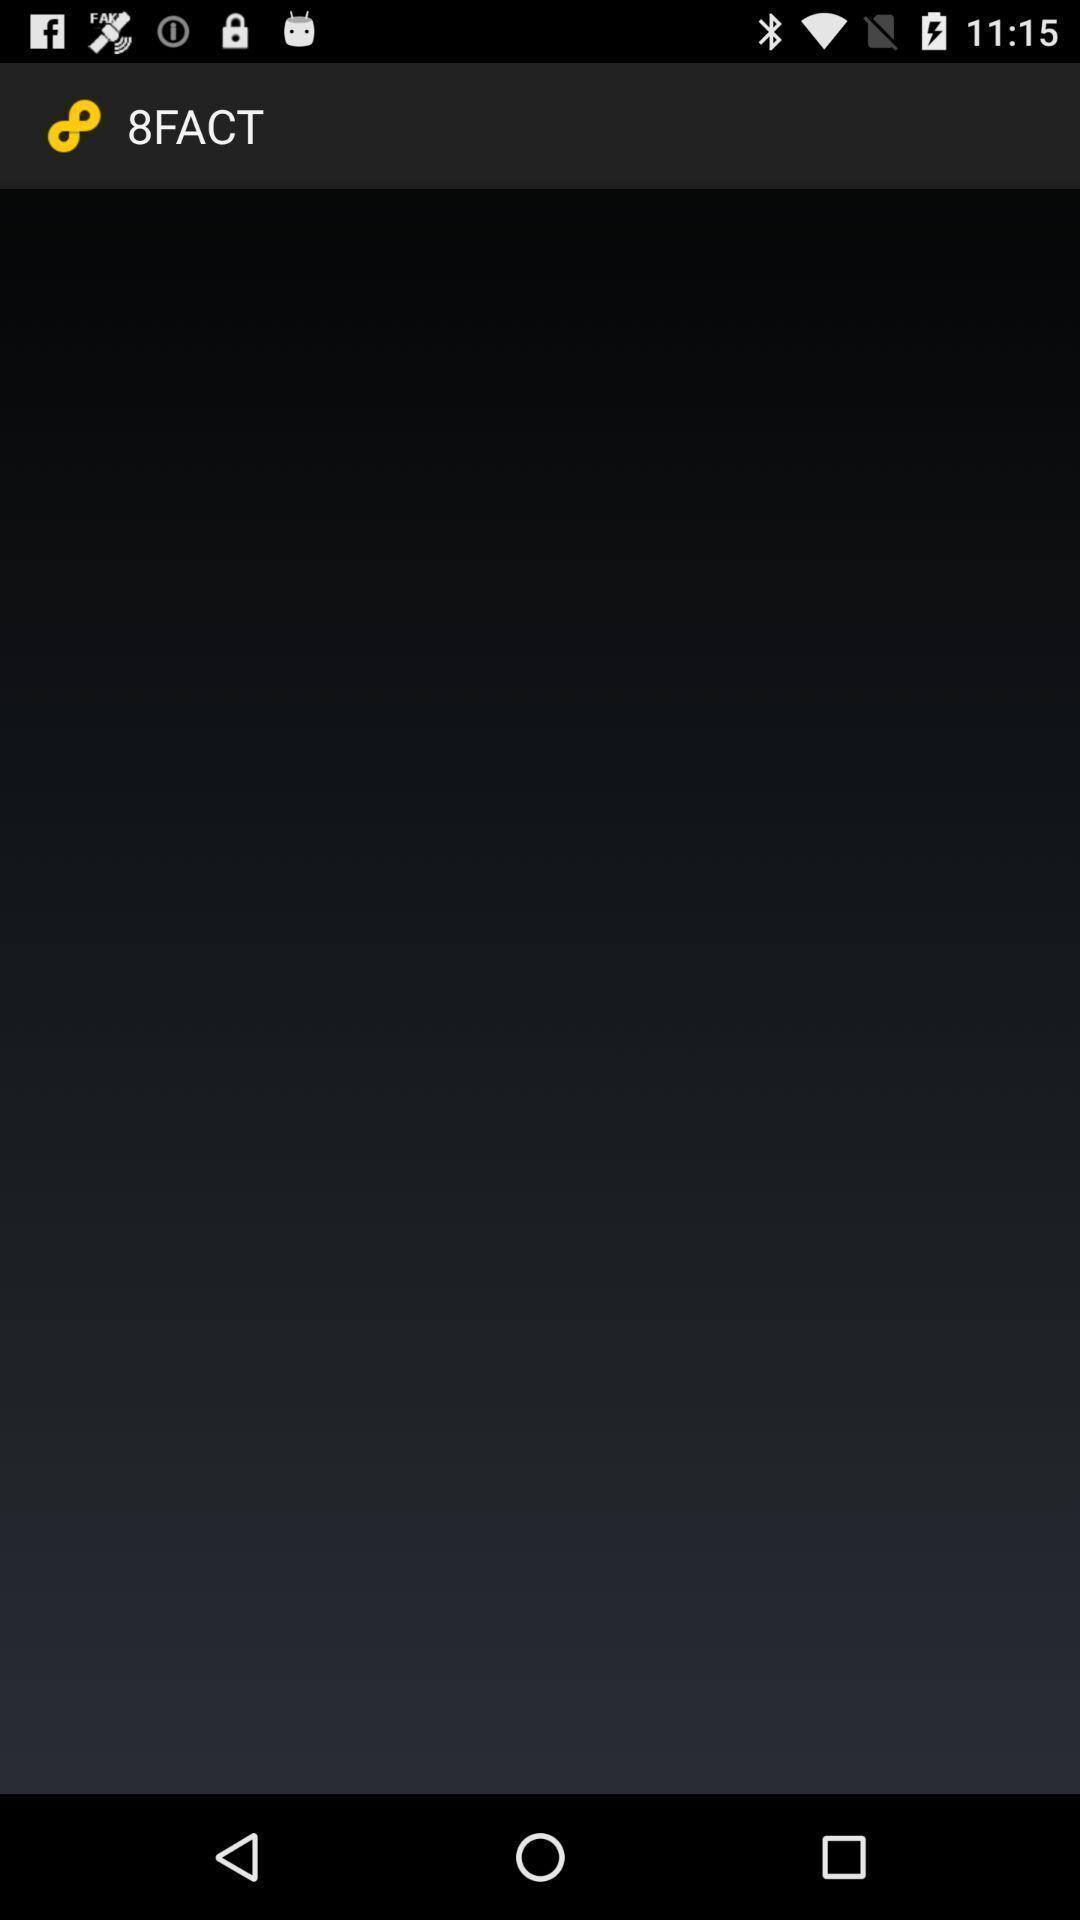What is the overall content of this screenshot? Page displaying blank for the facts app. 